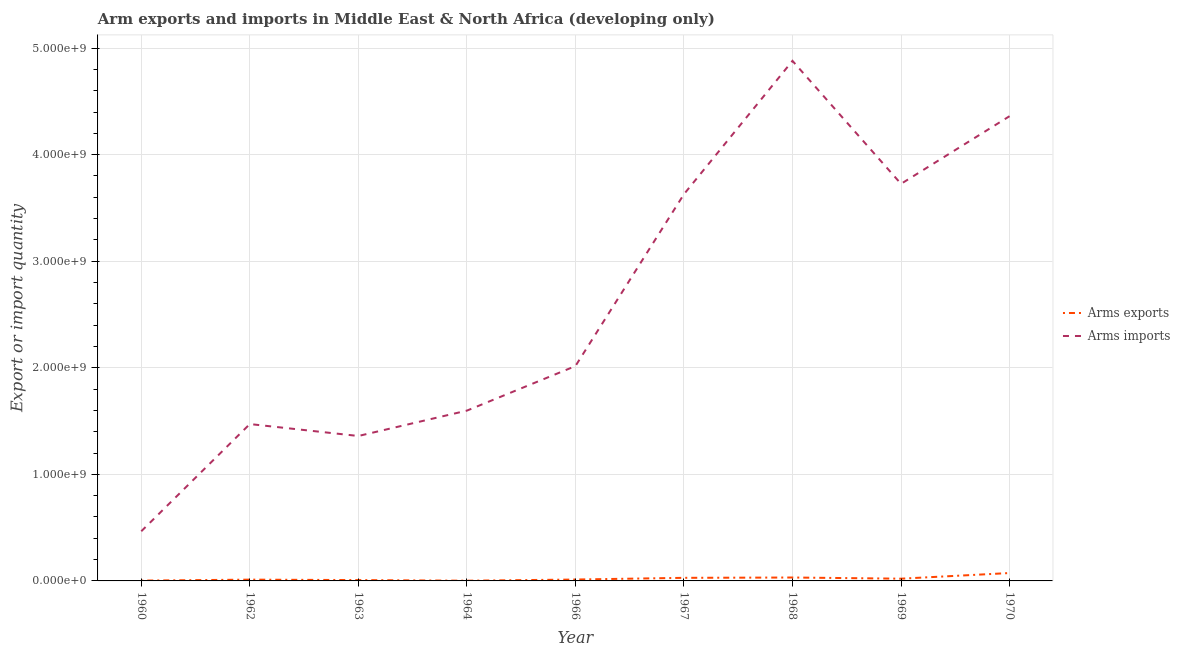Does the line corresponding to arms exports intersect with the line corresponding to arms imports?
Offer a terse response. No. What is the arms exports in 1962?
Ensure brevity in your answer.  1.20e+07. Across all years, what is the maximum arms exports?
Make the answer very short. 7.40e+07. Across all years, what is the minimum arms imports?
Your answer should be very brief. 4.66e+08. In which year was the arms exports maximum?
Keep it short and to the point. 1970. In which year was the arms exports minimum?
Your response must be concise. 1964. What is the total arms imports in the graph?
Your response must be concise. 2.35e+1. What is the difference between the arms exports in 1967 and that in 1969?
Provide a succinct answer. 8.00e+06. What is the difference between the arms imports in 1969 and the arms exports in 1963?
Your response must be concise. 3.72e+09. What is the average arms exports per year?
Offer a terse response. 2.16e+07. In the year 1968, what is the difference between the arms imports and arms exports?
Give a very brief answer. 4.85e+09. In how many years, is the arms imports greater than 1200000000?
Offer a terse response. 8. What is the ratio of the arms exports in 1963 to that in 1964?
Provide a succinct answer. 4. Is the arms imports in 1968 less than that in 1969?
Your response must be concise. No. What is the difference between the highest and the second highest arms imports?
Ensure brevity in your answer.  5.19e+08. What is the difference between the highest and the lowest arms imports?
Offer a very short reply. 4.41e+09. Is the arms exports strictly greater than the arms imports over the years?
Make the answer very short. No. Is the arms imports strictly less than the arms exports over the years?
Your answer should be compact. No. How many lines are there?
Your answer should be compact. 2. How many years are there in the graph?
Provide a short and direct response. 9. How many legend labels are there?
Keep it short and to the point. 2. How are the legend labels stacked?
Your answer should be compact. Vertical. What is the title of the graph?
Make the answer very short. Arm exports and imports in Middle East & North Africa (developing only). What is the label or title of the X-axis?
Your response must be concise. Year. What is the label or title of the Y-axis?
Your answer should be very brief. Export or import quantity. What is the Export or import quantity of Arms imports in 1960?
Your response must be concise. 4.66e+08. What is the Export or import quantity of Arms imports in 1962?
Your response must be concise. 1.47e+09. What is the Export or import quantity of Arms imports in 1963?
Keep it short and to the point. 1.36e+09. What is the Export or import quantity in Arms imports in 1964?
Keep it short and to the point. 1.60e+09. What is the Export or import quantity in Arms exports in 1966?
Your response must be concise. 1.30e+07. What is the Export or import quantity in Arms imports in 1966?
Offer a terse response. 2.02e+09. What is the Export or import quantity in Arms exports in 1967?
Keep it short and to the point. 2.90e+07. What is the Export or import quantity in Arms imports in 1967?
Ensure brevity in your answer.  3.63e+09. What is the Export or import quantity of Arms exports in 1968?
Your response must be concise. 3.20e+07. What is the Export or import quantity in Arms imports in 1968?
Offer a terse response. 4.88e+09. What is the Export or import quantity of Arms exports in 1969?
Ensure brevity in your answer.  2.10e+07. What is the Export or import quantity of Arms imports in 1969?
Your answer should be very brief. 3.73e+09. What is the Export or import quantity in Arms exports in 1970?
Provide a short and direct response. 7.40e+07. What is the Export or import quantity in Arms imports in 1970?
Your response must be concise. 4.36e+09. Across all years, what is the maximum Export or import quantity in Arms exports?
Your response must be concise. 7.40e+07. Across all years, what is the maximum Export or import quantity in Arms imports?
Your answer should be very brief. 4.88e+09. Across all years, what is the minimum Export or import quantity in Arms imports?
Provide a succinct answer. 4.66e+08. What is the total Export or import quantity in Arms exports in the graph?
Provide a short and direct response. 1.94e+08. What is the total Export or import quantity in Arms imports in the graph?
Give a very brief answer. 2.35e+1. What is the difference between the Export or import quantity of Arms exports in 1960 and that in 1962?
Make the answer very short. -9.00e+06. What is the difference between the Export or import quantity of Arms imports in 1960 and that in 1962?
Your answer should be very brief. -1.01e+09. What is the difference between the Export or import quantity in Arms exports in 1960 and that in 1963?
Make the answer very short. -5.00e+06. What is the difference between the Export or import quantity of Arms imports in 1960 and that in 1963?
Your answer should be compact. -8.94e+08. What is the difference between the Export or import quantity of Arms exports in 1960 and that in 1964?
Make the answer very short. 1.00e+06. What is the difference between the Export or import quantity of Arms imports in 1960 and that in 1964?
Keep it short and to the point. -1.13e+09. What is the difference between the Export or import quantity in Arms exports in 1960 and that in 1966?
Provide a succinct answer. -1.00e+07. What is the difference between the Export or import quantity of Arms imports in 1960 and that in 1966?
Give a very brief answer. -1.55e+09. What is the difference between the Export or import quantity of Arms exports in 1960 and that in 1967?
Give a very brief answer. -2.60e+07. What is the difference between the Export or import quantity in Arms imports in 1960 and that in 1967?
Keep it short and to the point. -3.16e+09. What is the difference between the Export or import quantity of Arms exports in 1960 and that in 1968?
Provide a short and direct response. -2.90e+07. What is the difference between the Export or import quantity in Arms imports in 1960 and that in 1968?
Make the answer very short. -4.41e+09. What is the difference between the Export or import quantity of Arms exports in 1960 and that in 1969?
Your response must be concise. -1.80e+07. What is the difference between the Export or import quantity of Arms imports in 1960 and that in 1969?
Offer a terse response. -3.26e+09. What is the difference between the Export or import quantity of Arms exports in 1960 and that in 1970?
Make the answer very short. -7.10e+07. What is the difference between the Export or import quantity in Arms imports in 1960 and that in 1970?
Offer a terse response. -3.90e+09. What is the difference between the Export or import quantity in Arms exports in 1962 and that in 1963?
Provide a succinct answer. 4.00e+06. What is the difference between the Export or import quantity of Arms imports in 1962 and that in 1963?
Provide a succinct answer. 1.12e+08. What is the difference between the Export or import quantity of Arms exports in 1962 and that in 1964?
Offer a very short reply. 1.00e+07. What is the difference between the Export or import quantity of Arms imports in 1962 and that in 1964?
Give a very brief answer. -1.26e+08. What is the difference between the Export or import quantity in Arms exports in 1962 and that in 1966?
Provide a succinct answer. -1.00e+06. What is the difference between the Export or import quantity in Arms imports in 1962 and that in 1966?
Your answer should be compact. -5.44e+08. What is the difference between the Export or import quantity in Arms exports in 1962 and that in 1967?
Keep it short and to the point. -1.70e+07. What is the difference between the Export or import quantity in Arms imports in 1962 and that in 1967?
Ensure brevity in your answer.  -2.16e+09. What is the difference between the Export or import quantity of Arms exports in 1962 and that in 1968?
Your answer should be compact. -2.00e+07. What is the difference between the Export or import quantity of Arms imports in 1962 and that in 1968?
Offer a terse response. -3.41e+09. What is the difference between the Export or import quantity in Arms exports in 1962 and that in 1969?
Provide a succinct answer. -9.00e+06. What is the difference between the Export or import quantity of Arms imports in 1962 and that in 1969?
Give a very brief answer. -2.25e+09. What is the difference between the Export or import quantity in Arms exports in 1962 and that in 1970?
Offer a very short reply. -6.20e+07. What is the difference between the Export or import quantity of Arms imports in 1962 and that in 1970?
Your response must be concise. -2.89e+09. What is the difference between the Export or import quantity in Arms exports in 1963 and that in 1964?
Provide a short and direct response. 6.00e+06. What is the difference between the Export or import quantity in Arms imports in 1963 and that in 1964?
Offer a terse response. -2.38e+08. What is the difference between the Export or import quantity of Arms exports in 1963 and that in 1966?
Ensure brevity in your answer.  -5.00e+06. What is the difference between the Export or import quantity in Arms imports in 1963 and that in 1966?
Your answer should be compact. -6.56e+08. What is the difference between the Export or import quantity in Arms exports in 1963 and that in 1967?
Your answer should be very brief. -2.10e+07. What is the difference between the Export or import quantity of Arms imports in 1963 and that in 1967?
Offer a terse response. -2.27e+09. What is the difference between the Export or import quantity of Arms exports in 1963 and that in 1968?
Ensure brevity in your answer.  -2.40e+07. What is the difference between the Export or import quantity of Arms imports in 1963 and that in 1968?
Make the answer very short. -3.52e+09. What is the difference between the Export or import quantity of Arms exports in 1963 and that in 1969?
Give a very brief answer. -1.30e+07. What is the difference between the Export or import quantity of Arms imports in 1963 and that in 1969?
Provide a succinct answer. -2.37e+09. What is the difference between the Export or import quantity in Arms exports in 1963 and that in 1970?
Offer a very short reply. -6.60e+07. What is the difference between the Export or import quantity of Arms imports in 1963 and that in 1970?
Your answer should be very brief. -3.00e+09. What is the difference between the Export or import quantity in Arms exports in 1964 and that in 1966?
Your answer should be very brief. -1.10e+07. What is the difference between the Export or import quantity in Arms imports in 1964 and that in 1966?
Ensure brevity in your answer.  -4.18e+08. What is the difference between the Export or import quantity in Arms exports in 1964 and that in 1967?
Provide a succinct answer. -2.70e+07. What is the difference between the Export or import quantity of Arms imports in 1964 and that in 1967?
Keep it short and to the point. -2.03e+09. What is the difference between the Export or import quantity of Arms exports in 1964 and that in 1968?
Offer a very short reply. -3.00e+07. What is the difference between the Export or import quantity in Arms imports in 1964 and that in 1968?
Ensure brevity in your answer.  -3.28e+09. What is the difference between the Export or import quantity of Arms exports in 1964 and that in 1969?
Provide a succinct answer. -1.90e+07. What is the difference between the Export or import quantity of Arms imports in 1964 and that in 1969?
Provide a succinct answer. -2.13e+09. What is the difference between the Export or import quantity in Arms exports in 1964 and that in 1970?
Your answer should be very brief. -7.20e+07. What is the difference between the Export or import quantity in Arms imports in 1964 and that in 1970?
Give a very brief answer. -2.76e+09. What is the difference between the Export or import quantity in Arms exports in 1966 and that in 1967?
Offer a very short reply. -1.60e+07. What is the difference between the Export or import quantity in Arms imports in 1966 and that in 1967?
Give a very brief answer. -1.61e+09. What is the difference between the Export or import quantity of Arms exports in 1966 and that in 1968?
Offer a very short reply. -1.90e+07. What is the difference between the Export or import quantity in Arms imports in 1966 and that in 1968?
Offer a very short reply. -2.86e+09. What is the difference between the Export or import quantity of Arms exports in 1966 and that in 1969?
Your response must be concise. -8.00e+06. What is the difference between the Export or import quantity of Arms imports in 1966 and that in 1969?
Ensure brevity in your answer.  -1.71e+09. What is the difference between the Export or import quantity in Arms exports in 1966 and that in 1970?
Give a very brief answer. -6.10e+07. What is the difference between the Export or import quantity of Arms imports in 1966 and that in 1970?
Provide a short and direct response. -2.34e+09. What is the difference between the Export or import quantity of Arms imports in 1967 and that in 1968?
Offer a very short reply. -1.25e+09. What is the difference between the Export or import quantity in Arms imports in 1967 and that in 1969?
Keep it short and to the point. -9.70e+07. What is the difference between the Export or import quantity of Arms exports in 1967 and that in 1970?
Keep it short and to the point. -4.50e+07. What is the difference between the Export or import quantity in Arms imports in 1967 and that in 1970?
Offer a terse response. -7.32e+08. What is the difference between the Export or import quantity of Arms exports in 1968 and that in 1969?
Your answer should be compact. 1.10e+07. What is the difference between the Export or import quantity of Arms imports in 1968 and that in 1969?
Your answer should be compact. 1.15e+09. What is the difference between the Export or import quantity in Arms exports in 1968 and that in 1970?
Give a very brief answer. -4.20e+07. What is the difference between the Export or import quantity in Arms imports in 1968 and that in 1970?
Your response must be concise. 5.19e+08. What is the difference between the Export or import quantity of Arms exports in 1969 and that in 1970?
Provide a short and direct response. -5.30e+07. What is the difference between the Export or import quantity of Arms imports in 1969 and that in 1970?
Make the answer very short. -6.35e+08. What is the difference between the Export or import quantity in Arms exports in 1960 and the Export or import quantity in Arms imports in 1962?
Provide a short and direct response. -1.47e+09. What is the difference between the Export or import quantity of Arms exports in 1960 and the Export or import quantity of Arms imports in 1963?
Provide a short and direct response. -1.36e+09. What is the difference between the Export or import quantity of Arms exports in 1960 and the Export or import quantity of Arms imports in 1964?
Your answer should be very brief. -1.60e+09. What is the difference between the Export or import quantity in Arms exports in 1960 and the Export or import quantity in Arms imports in 1966?
Keep it short and to the point. -2.01e+09. What is the difference between the Export or import quantity in Arms exports in 1960 and the Export or import quantity in Arms imports in 1967?
Offer a very short reply. -3.63e+09. What is the difference between the Export or import quantity of Arms exports in 1960 and the Export or import quantity of Arms imports in 1968?
Your response must be concise. -4.88e+09. What is the difference between the Export or import quantity in Arms exports in 1960 and the Export or import quantity in Arms imports in 1969?
Your answer should be very brief. -3.72e+09. What is the difference between the Export or import quantity in Arms exports in 1960 and the Export or import quantity in Arms imports in 1970?
Your response must be concise. -4.36e+09. What is the difference between the Export or import quantity of Arms exports in 1962 and the Export or import quantity of Arms imports in 1963?
Your answer should be compact. -1.35e+09. What is the difference between the Export or import quantity of Arms exports in 1962 and the Export or import quantity of Arms imports in 1964?
Provide a succinct answer. -1.59e+09. What is the difference between the Export or import quantity in Arms exports in 1962 and the Export or import quantity in Arms imports in 1966?
Your answer should be very brief. -2.00e+09. What is the difference between the Export or import quantity of Arms exports in 1962 and the Export or import quantity of Arms imports in 1967?
Provide a short and direct response. -3.62e+09. What is the difference between the Export or import quantity in Arms exports in 1962 and the Export or import quantity in Arms imports in 1968?
Offer a very short reply. -4.87e+09. What is the difference between the Export or import quantity in Arms exports in 1962 and the Export or import quantity in Arms imports in 1969?
Provide a succinct answer. -3.71e+09. What is the difference between the Export or import quantity in Arms exports in 1962 and the Export or import quantity in Arms imports in 1970?
Offer a very short reply. -4.35e+09. What is the difference between the Export or import quantity in Arms exports in 1963 and the Export or import quantity in Arms imports in 1964?
Your answer should be compact. -1.59e+09. What is the difference between the Export or import quantity of Arms exports in 1963 and the Export or import quantity of Arms imports in 1966?
Your response must be concise. -2.01e+09. What is the difference between the Export or import quantity in Arms exports in 1963 and the Export or import quantity in Arms imports in 1967?
Provide a succinct answer. -3.62e+09. What is the difference between the Export or import quantity in Arms exports in 1963 and the Export or import quantity in Arms imports in 1968?
Provide a succinct answer. -4.87e+09. What is the difference between the Export or import quantity of Arms exports in 1963 and the Export or import quantity of Arms imports in 1969?
Offer a terse response. -3.72e+09. What is the difference between the Export or import quantity of Arms exports in 1963 and the Export or import quantity of Arms imports in 1970?
Provide a succinct answer. -4.35e+09. What is the difference between the Export or import quantity in Arms exports in 1964 and the Export or import quantity in Arms imports in 1966?
Your response must be concise. -2.01e+09. What is the difference between the Export or import quantity of Arms exports in 1964 and the Export or import quantity of Arms imports in 1967?
Ensure brevity in your answer.  -3.63e+09. What is the difference between the Export or import quantity in Arms exports in 1964 and the Export or import quantity in Arms imports in 1968?
Offer a very short reply. -4.88e+09. What is the difference between the Export or import quantity in Arms exports in 1964 and the Export or import quantity in Arms imports in 1969?
Provide a short and direct response. -3.72e+09. What is the difference between the Export or import quantity in Arms exports in 1964 and the Export or import quantity in Arms imports in 1970?
Provide a short and direct response. -4.36e+09. What is the difference between the Export or import quantity of Arms exports in 1966 and the Export or import quantity of Arms imports in 1967?
Offer a terse response. -3.62e+09. What is the difference between the Export or import quantity in Arms exports in 1966 and the Export or import quantity in Arms imports in 1968?
Your answer should be compact. -4.87e+09. What is the difference between the Export or import quantity in Arms exports in 1966 and the Export or import quantity in Arms imports in 1969?
Your answer should be compact. -3.71e+09. What is the difference between the Export or import quantity of Arms exports in 1966 and the Export or import quantity of Arms imports in 1970?
Offer a very short reply. -4.35e+09. What is the difference between the Export or import quantity of Arms exports in 1967 and the Export or import quantity of Arms imports in 1968?
Offer a terse response. -4.85e+09. What is the difference between the Export or import quantity in Arms exports in 1967 and the Export or import quantity in Arms imports in 1969?
Provide a succinct answer. -3.70e+09. What is the difference between the Export or import quantity of Arms exports in 1967 and the Export or import quantity of Arms imports in 1970?
Your answer should be very brief. -4.33e+09. What is the difference between the Export or import quantity of Arms exports in 1968 and the Export or import quantity of Arms imports in 1969?
Keep it short and to the point. -3.69e+09. What is the difference between the Export or import quantity of Arms exports in 1968 and the Export or import quantity of Arms imports in 1970?
Offer a terse response. -4.33e+09. What is the difference between the Export or import quantity in Arms exports in 1969 and the Export or import quantity in Arms imports in 1970?
Offer a terse response. -4.34e+09. What is the average Export or import quantity of Arms exports per year?
Keep it short and to the point. 2.16e+07. What is the average Export or import quantity in Arms imports per year?
Make the answer very short. 2.61e+09. In the year 1960, what is the difference between the Export or import quantity of Arms exports and Export or import quantity of Arms imports?
Provide a short and direct response. -4.63e+08. In the year 1962, what is the difference between the Export or import quantity in Arms exports and Export or import quantity in Arms imports?
Provide a succinct answer. -1.46e+09. In the year 1963, what is the difference between the Export or import quantity of Arms exports and Export or import quantity of Arms imports?
Offer a very short reply. -1.35e+09. In the year 1964, what is the difference between the Export or import quantity of Arms exports and Export or import quantity of Arms imports?
Your response must be concise. -1.60e+09. In the year 1966, what is the difference between the Export or import quantity in Arms exports and Export or import quantity in Arms imports?
Offer a very short reply. -2.00e+09. In the year 1967, what is the difference between the Export or import quantity in Arms exports and Export or import quantity in Arms imports?
Your answer should be compact. -3.60e+09. In the year 1968, what is the difference between the Export or import quantity of Arms exports and Export or import quantity of Arms imports?
Your answer should be very brief. -4.85e+09. In the year 1969, what is the difference between the Export or import quantity of Arms exports and Export or import quantity of Arms imports?
Offer a very short reply. -3.70e+09. In the year 1970, what is the difference between the Export or import quantity in Arms exports and Export or import quantity in Arms imports?
Keep it short and to the point. -4.29e+09. What is the ratio of the Export or import quantity of Arms exports in 1960 to that in 1962?
Your answer should be very brief. 0.25. What is the ratio of the Export or import quantity in Arms imports in 1960 to that in 1962?
Provide a succinct answer. 0.32. What is the ratio of the Export or import quantity in Arms imports in 1960 to that in 1963?
Give a very brief answer. 0.34. What is the ratio of the Export or import quantity of Arms exports in 1960 to that in 1964?
Your answer should be very brief. 1.5. What is the ratio of the Export or import quantity in Arms imports in 1960 to that in 1964?
Your answer should be very brief. 0.29. What is the ratio of the Export or import quantity of Arms exports in 1960 to that in 1966?
Your response must be concise. 0.23. What is the ratio of the Export or import quantity of Arms imports in 1960 to that in 1966?
Your answer should be compact. 0.23. What is the ratio of the Export or import quantity in Arms exports in 1960 to that in 1967?
Provide a succinct answer. 0.1. What is the ratio of the Export or import quantity in Arms imports in 1960 to that in 1967?
Provide a short and direct response. 0.13. What is the ratio of the Export or import quantity in Arms exports in 1960 to that in 1968?
Provide a succinct answer. 0.09. What is the ratio of the Export or import quantity of Arms imports in 1960 to that in 1968?
Provide a succinct answer. 0.1. What is the ratio of the Export or import quantity in Arms exports in 1960 to that in 1969?
Offer a terse response. 0.14. What is the ratio of the Export or import quantity in Arms imports in 1960 to that in 1969?
Make the answer very short. 0.13. What is the ratio of the Export or import quantity in Arms exports in 1960 to that in 1970?
Offer a terse response. 0.04. What is the ratio of the Export or import quantity of Arms imports in 1960 to that in 1970?
Provide a short and direct response. 0.11. What is the ratio of the Export or import quantity in Arms imports in 1962 to that in 1963?
Provide a succinct answer. 1.08. What is the ratio of the Export or import quantity in Arms imports in 1962 to that in 1964?
Ensure brevity in your answer.  0.92. What is the ratio of the Export or import quantity in Arms exports in 1962 to that in 1966?
Provide a succinct answer. 0.92. What is the ratio of the Export or import quantity in Arms imports in 1962 to that in 1966?
Provide a succinct answer. 0.73. What is the ratio of the Export or import quantity of Arms exports in 1962 to that in 1967?
Your answer should be compact. 0.41. What is the ratio of the Export or import quantity in Arms imports in 1962 to that in 1967?
Provide a short and direct response. 0.41. What is the ratio of the Export or import quantity of Arms imports in 1962 to that in 1968?
Ensure brevity in your answer.  0.3. What is the ratio of the Export or import quantity of Arms exports in 1962 to that in 1969?
Offer a very short reply. 0.57. What is the ratio of the Export or import quantity of Arms imports in 1962 to that in 1969?
Ensure brevity in your answer.  0.4. What is the ratio of the Export or import quantity in Arms exports in 1962 to that in 1970?
Your answer should be very brief. 0.16. What is the ratio of the Export or import quantity of Arms imports in 1962 to that in 1970?
Provide a succinct answer. 0.34. What is the ratio of the Export or import quantity in Arms imports in 1963 to that in 1964?
Provide a succinct answer. 0.85. What is the ratio of the Export or import quantity in Arms exports in 1963 to that in 1966?
Offer a very short reply. 0.62. What is the ratio of the Export or import quantity in Arms imports in 1963 to that in 1966?
Provide a short and direct response. 0.67. What is the ratio of the Export or import quantity in Arms exports in 1963 to that in 1967?
Offer a terse response. 0.28. What is the ratio of the Export or import quantity in Arms imports in 1963 to that in 1967?
Provide a succinct answer. 0.37. What is the ratio of the Export or import quantity in Arms exports in 1963 to that in 1968?
Provide a short and direct response. 0.25. What is the ratio of the Export or import quantity in Arms imports in 1963 to that in 1968?
Make the answer very short. 0.28. What is the ratio of the Export or import quantity in Arms exports in 1963 to that in 1969?
Offer a terse response. 0.38. What is the ratio of the Export or import quantity in Arms imports in 1963 to that in 1969?
Provide a short and direct response. 0.36. What is the ratio of the Export or import quantity in Arms exports in 1963 to that in 1970?
Offer a very short reply. 0.11. What is the ratio of the Export or import quantity in Arms imports in 1963 to that in 1970?
Make the answer very short. 0.31. What is the ratio of the Export or import quantity in Arms exports in 1964 to that in 1966?
Your answer should be very brief. 0.15. What is the ratio of the Export or import quantity in Arms imports in 1964 to that in 1966?
Ensure brevity in your answer.  0.79. What is the ratio of the Export or import quantity in Arms exports in 1964 to that in 1967?
Your answer should be very brief. 0.07. What is the ratio of the Export or import quantity in Arms imports in 1964 to that in 1967?
Make the answer very short. 0.44. What is the ratio of the Export or import quantity of Arms exports in 1964 to that in 1968?
Offer a terse response. 0.06. What is the ratio of the Export or import quantity in Arms imports in 1964 to that in 1968?
Offer a terse response. 0.33. What is the ratio of the Export or import quantity of Arms exports in 1964 to that in 1969?
Your answer should be very brief. 0.1. What is the ratio of the Export or import quantity of Arms imports in 1964 to that in 1969?
Offer a terse response. 0.43. What is the ratio of the Export or import quantity in Arms exports in 1964 to that in 1970?
Make the answer very short. 0.03. What is the ratio of the Export or import quantity of Arms imports in 1964 to that in 1970?
Ensure brevity in your answer.  0.37. What is the ratio of the Export or import quantity of Arms exports in 1966 to that in 1967?
Offer a terse response. 0.45. What is the ratio of the Export or import quantity in Arms imports in 1966 to that in 1967?
Provide a succinct answer. 0.56. What is the ratio of the Export or import quantity in Arms exports in 1966 to that in 1968?
Keep it short and to the point. 0.41. What is the ratio of the Export or import quantity of Arms imports in 1966 to that in 1968?
Give a very brief answer. 0.41. What is the ratio of the Export or import quantity in Arms exports in 1966 to that in 1969?
Ensure brevity in your answer.  0.62. What is the ratio of the Export or import quantity in Arms imports in 1966 to that in 1969?
Provide a short and direct response. 0.54. What is the ratio of the Export or import quantity of Arms exports in 1966 to that in 1970?
Provide a short and direct response. 0.18. What is the ratio of the Export or import quantity of Arms imports in 1966 to that in 1970?
Your answer should be compact. 0.46. What is the ratio of the Export or import quantity in Arms exports in 1967 to that in 1968?
Keep it short and to the point. 0.91. What is the ratio of the Export or import quantity in Arms imports in 1967 to that in 1968?
Ensure brevity in your answer.  0.74. What is the ratio of the Export or import quantity of Arms exports in 1967 to that in 1969?
Offer a terse response. 1.38. What is the ratio of the Export or import quantity of Arms exports in 1967 to that in 1970?
Make the answer very short. 0.39. What is the ratio of the Export or import quantity in Arms imports in 1967 to that in 1970?
Your answer should be compact. 0.83. What is the ratio of the Export or import quantity in Arms exports in 1968 to that in 1969?
Provide a short and direct response. 1.52. What is the ratio of the Export or import quantity in Arms imports in 1968 to that in 1969?
Your answer should be very brief. 1.31. What is the ratio of the Export or import quantity of Arms exports in 1968 to that in 1970?
Ensure brevity in your answer.  0.43. What is the ratio of the Export or import quantity in Arms imports in 1968 to that in 1970?
Your response must be concise. 1.12. What is the ratio of the Export or import quantity in Arms exports in 1969 to that in 1970?
Ensure brevity in your answer.  0.28. What is the ratio of the Export or import quantity in Arms imports in 1969 to that in 1970?
Your response must be concise. 0.85. What is the difference between the highest and the second highest Export or import quantity of Arms exports?
Your answer should be compact. 4.20e+07. What is the difference between the highest and the second highest Export or import quantity in Arms imports?
Your response must be concise. 5.19e+08. What is the difference between the highest and the lowest Export or import quantity of Arms exports?
Provide a short and direct response. 7.20e+07. What is the difference between the highest and the lowest Export or import quantity in Arms imports?
Provide a succinct answer. 4.41e+09. 